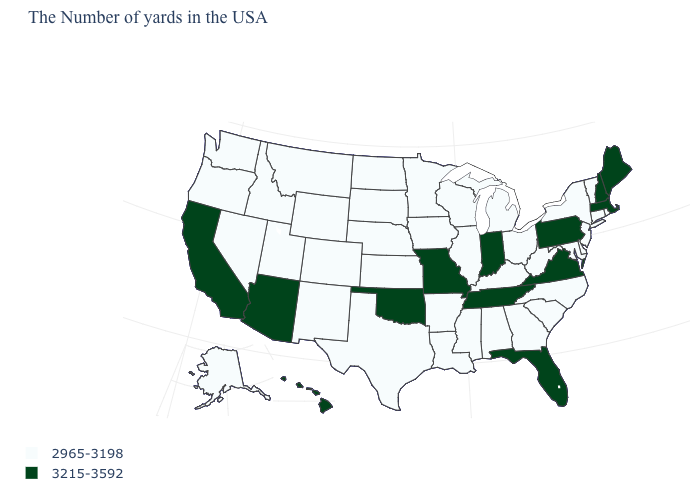Is the legend a continuous bar?
Keep it brief. No. What is the value of Virginia?
Write a very short answer. 3215-3592. What is the value of Idaho?
Short answer required. 2965-3198. Name the states that have a value in the range 2965-3198?
Give a very brief answer. Rhode Island, Vermont, Connecticut, New York, New Jersey, Delaware, Maryland, North Carolina, South Carolina, West Virginia, Ohio, Georgia, Michigan, Kentucky, Alabama, Wisconsin, Illinois, Mississippi, Louisiana, Arkansas, Minnesota, Iowa, Kansas, Nebraska, Texas, South Dakota, North Dakota, Wyoming, Colorado, New Mexico, Utah, Montana, Idaho, Nevada, Washington, Oregon, Alaska. What is the value of North Dakota?
Answer briefly. 2965-3198. How many symbols are there in the legend?
Write a very short answer. 2. Name the states that have a value in the range 3215-3592?
Give a very brief answer. Maine, Massachusetts, New Hampshire, Pennsylvania, Virginia, Florida, Indiana, Tennessee, Missouri, Oklahoma, Arizona, California, Hawaii. What is the lowest value in the MidWest?
Answer briefly. 2965-3198. What is the value of Idaho?
Quick response, please. 2965-3198. Name the states that have a value in the range 2965-3198?
Quick response, please. Rhode Island, Vermont, Connecticut, New York, New Jersey, Delaware, Maryland, North Carolina, South Carolina, West Virginia, Ohio, Georgia, Michigan, Kentucky, Alabama, Wisconsin, Illinois, Mississippi, Louisiana, Arkansas, Minnesota, Iowa, Kansas, Nebraska, Texas, South Dakota, North Dakota, Wyoming, Colorado, New Mexico, Utah, Montana, Idaho, Nevada, Washington, Oregon, Alaska. Is the legend a continuous bar?
Short answer required. No. Name the states that have a value in the range 3215-3592?
Answer briefly. Maine, Massachusetts, New Hampshire, Pennsylvania, Virginia, Florida, Indiana, Tennessee, Missouri, Oklahoma, Arizona, California, Hawaii. Does the first symbol in the legend represent the smallest category?
Answer briefly. Yes. Among the states that border Nebraska , does South Dakota have the lowest value?
Give a very brief answer. Yes. 